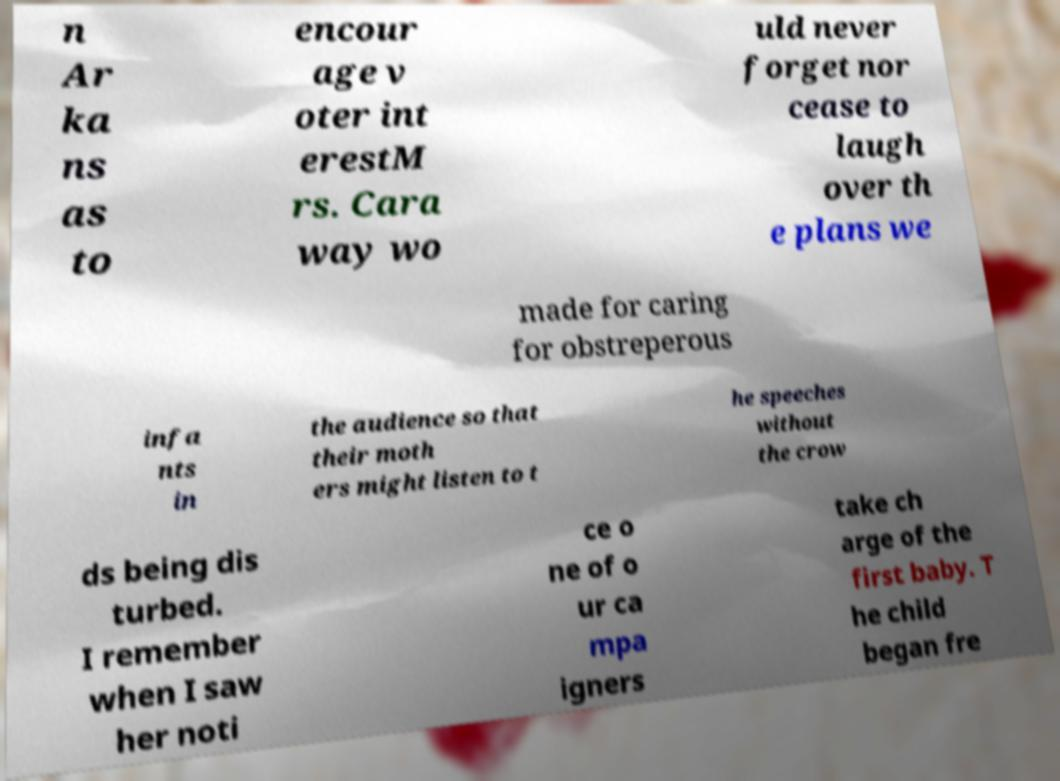There's text embedded in this image that I need extracted. Can you transcribe it verbatim? n Ar ka ns as to encour age v oter int erestM rs. Cara way wo uld never forget nor cease to laugh over th e plans we made for caring for obstreperous infa nts in the audience so that their moth ers might listen to t he speeches without the crow ds being dis turbed. I remember when I saw her noti ce o ne of o ur ca mpa igners take ch arge of the first baby. T he child began fre 